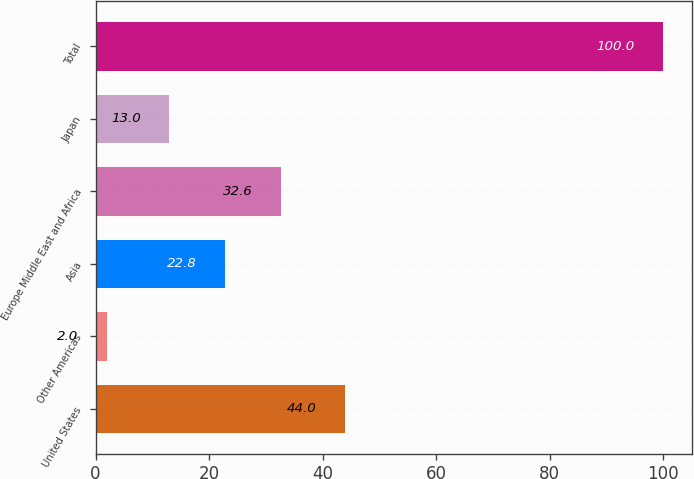Convert chart to OTSL. <chart><loc_0><loc_0><loc_500><loc_500><bar_chart><fcel>United States<fcel>Other Americas<fcel>Asia<fcel>Europe Middle East and Africa<fcel>Japan<fcel>Total<nl><fcel>44<fcel>2<fcel>22.8<fcel>32.6<fcel>13<fcel>100<nl></chart> 